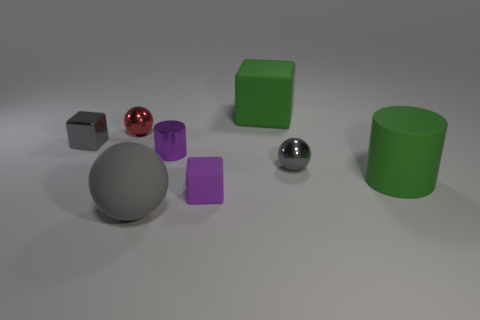What number of red metallic objects have the same shape as the purple matte object?
Make the answer very short. 0. Do the tiny metallic cylinder and the tiny rubber block have the same color?
Provide a short and direct response. Yes. Are there any tiny cylinders of the same color as the tiny rubber cube?
Your answer should be compact. Yes. Are the tiny ball to the left of the large sphere and the big green thing that is left of the large green cylinder made of the same material?
Ensure brevity in your answer.  No. The matte cylinder has what color?
Offer a very short reply. Green. How big is the gray thing that is in front of the metal sphere in front of the tiny gray shiny object that is left of the purple cube?
Give a very brief answer. Large. How many other objects are there of the same size as the purple rubber cube?
Offer a very short reply. 4. What number of small cylinders have the same material as the small red thing?
Make the answer very short. 1. What shape is the tiny gray object that is on the left side of the tiny red thing?
Keep it short and to the point. Cube. Does the large green block have the same material as the tiny sphere that is behind the small purple metal cylinder?
Your answer should be very brief. No. 